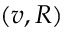Convert formula to latex. <formula><loc_0><loc_0><loc_500><loc_500>( v , R )</formula> 